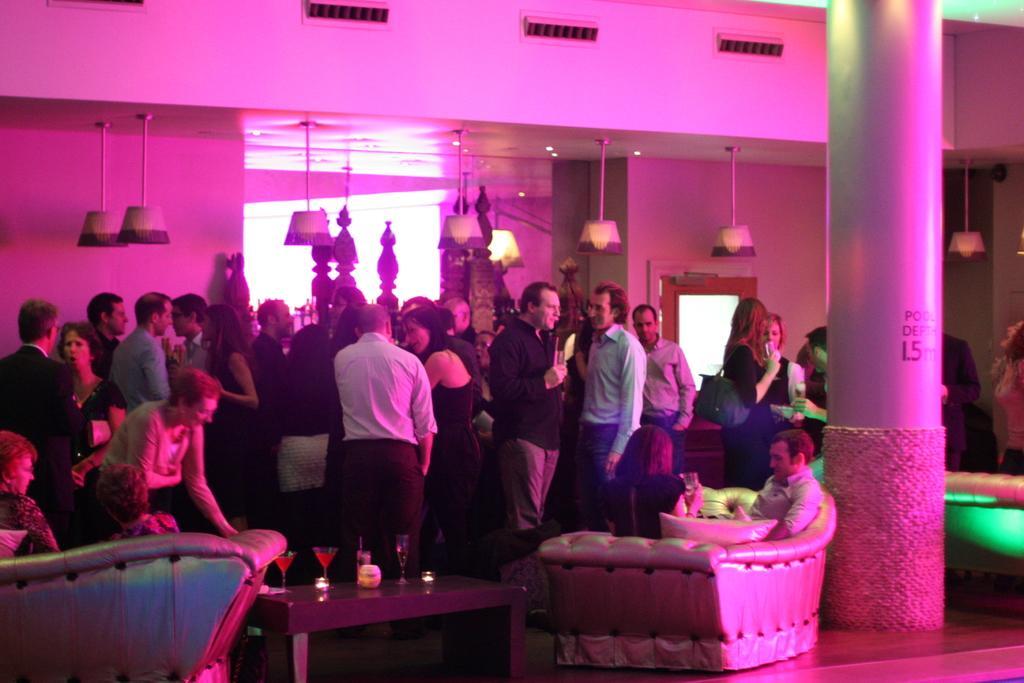Could you give a brief overview of what you see in this image? In this image in the center there are persons standing and sitting and there are lights hanging on the top. On the left side there are persons sitting on the sofa. In the center there is a table and on the table there are glasses. On the right side there is a pillar with some text written on it and in the background there is a door. 